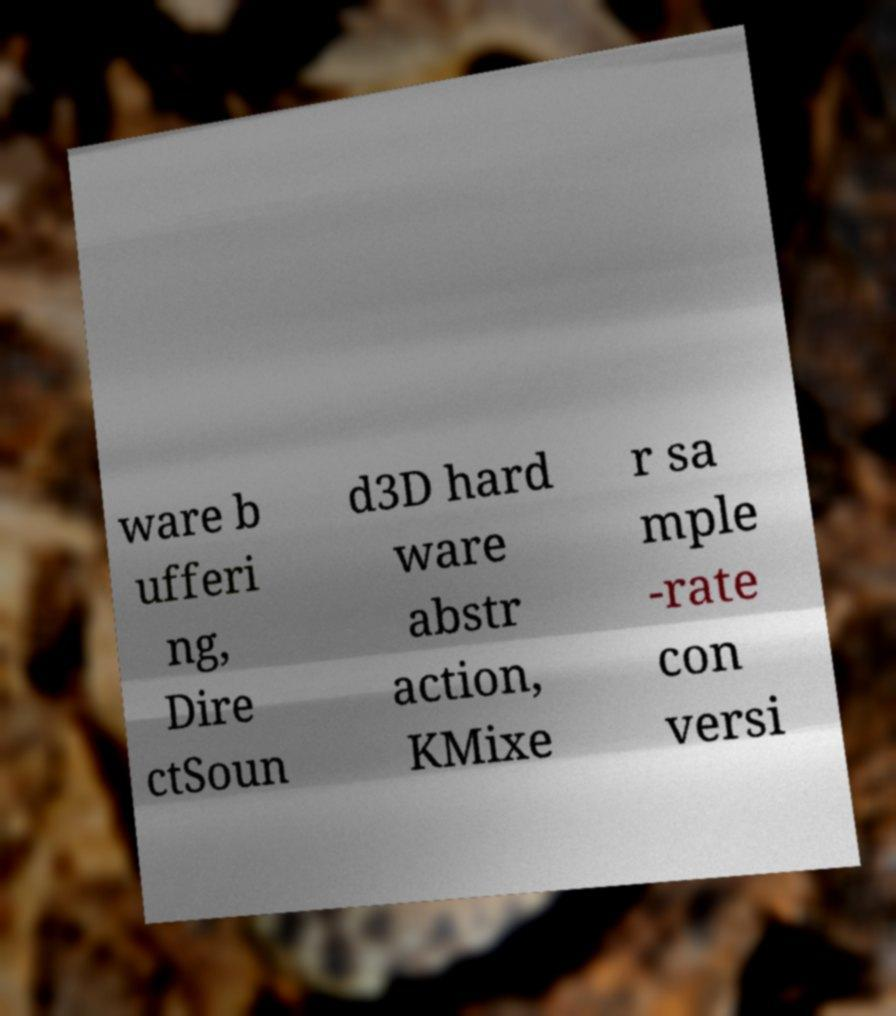Please read and relay the text visible in this image. What does it say? ware b ufferi ng, Dire ctSoun d3D hard ware abstr action, KMixe r sa mple -rate con versi 